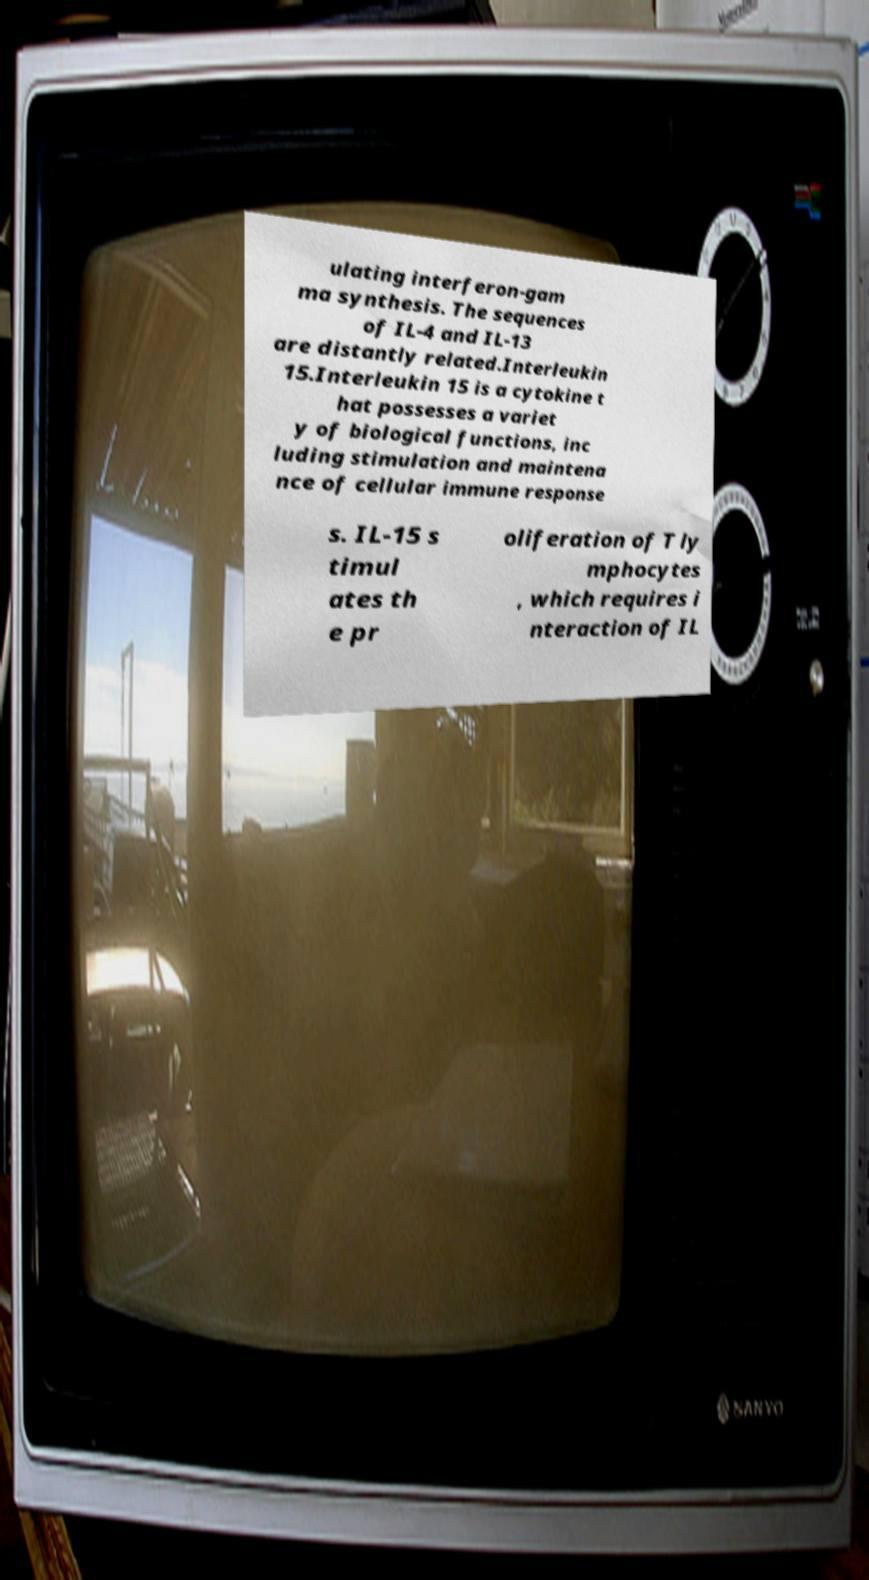Can you read and provide the text displayed in the image?This photo seems to have some interesting text. Can you extract and type it out for me? ulating interferon-gam ma synthesis. The sequences of IL-4 and IL-13 are distantly related.Interleukin 15.Interleukin 15 is a cytokine t hat possesses a variet y of biological functions, inc luding stimulation and maintena nce of cellular immune response s. IL-15 s timul ates th e pr oliferation of T ly mphocytes , which requires i nteraction of IL 